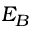Convert formula to latex. <formula><loc_0><loc_0><loc_500><loc_500>E _ { B }</formula> 